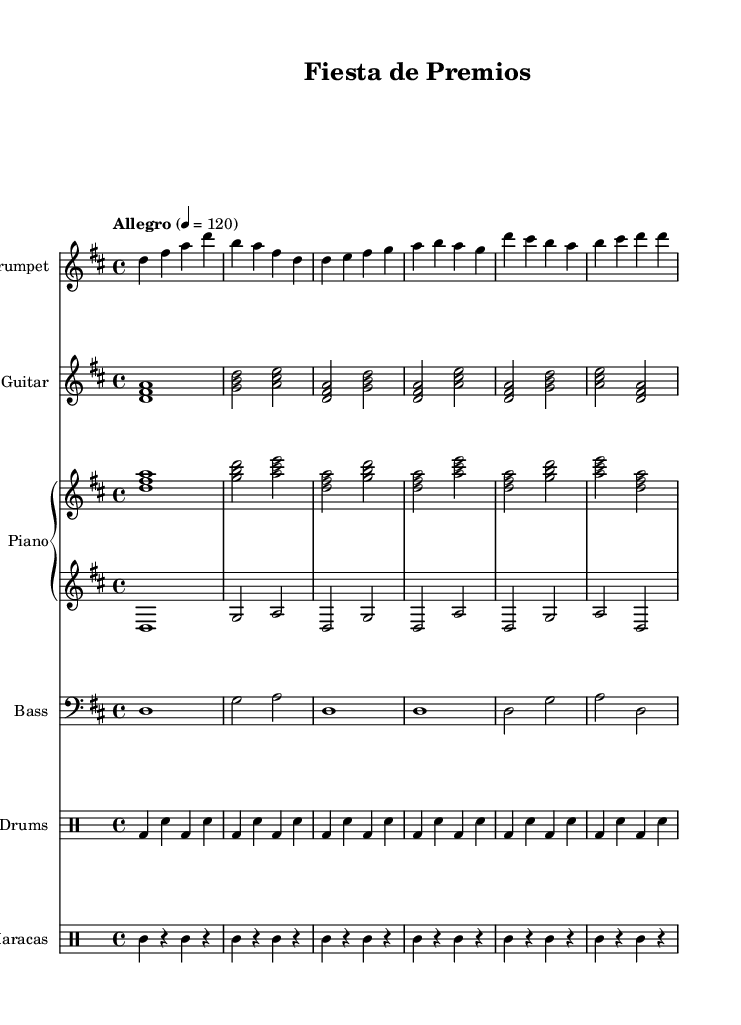What is the key signature of this music? The key signature is D major, indicated by the presence of two sharps (F# and C#) in the key signature at the beginning of the staff.
Answer: D major What is the time signature of this music? The time signature is 4/4, which means there are four beats in each measure and the quarter note gets one beat. This is marked at the beginning of the score.
Answer: 4/4 What is the tempo marking of this music? The tempo marking is "Allegro" indicating a fast and lively tempo, with a metronome marking of 120 beats per minute. This can be found in the tempo section at the beginning.
Answer: Allegro How many beats are in each measure? Each measure contains four beats, which corresponds with the 4/4 time signature, where each quarter note counts as one beat.
Answer: Four Which instruments are included in this score? The instruments included are Trumpet, Guitar, Piano (with right and left hand parts), Bass, Drums, and Maracas, as indicated at the start of each staff in the score.
Answer: Trumpet, Guitar, Piano, Bass, Drums, Maracas What type of music fusion is represented in this piece? The piece combines elements of traditional Mexican folk music with jazz influences, characterized by upbeat rhythms, lively melodies, and integration of various instruments typical of both styles.
Answer: Folk-jazz fusion What rhythmic patterns do the maracas play? The maracas play a repeating pattern of quarter notes followed by rests, which contributes to the rhythmic feel of the piece. This can be identified by examining the maracas part in the score.
Answer: Quarter notes and rests 